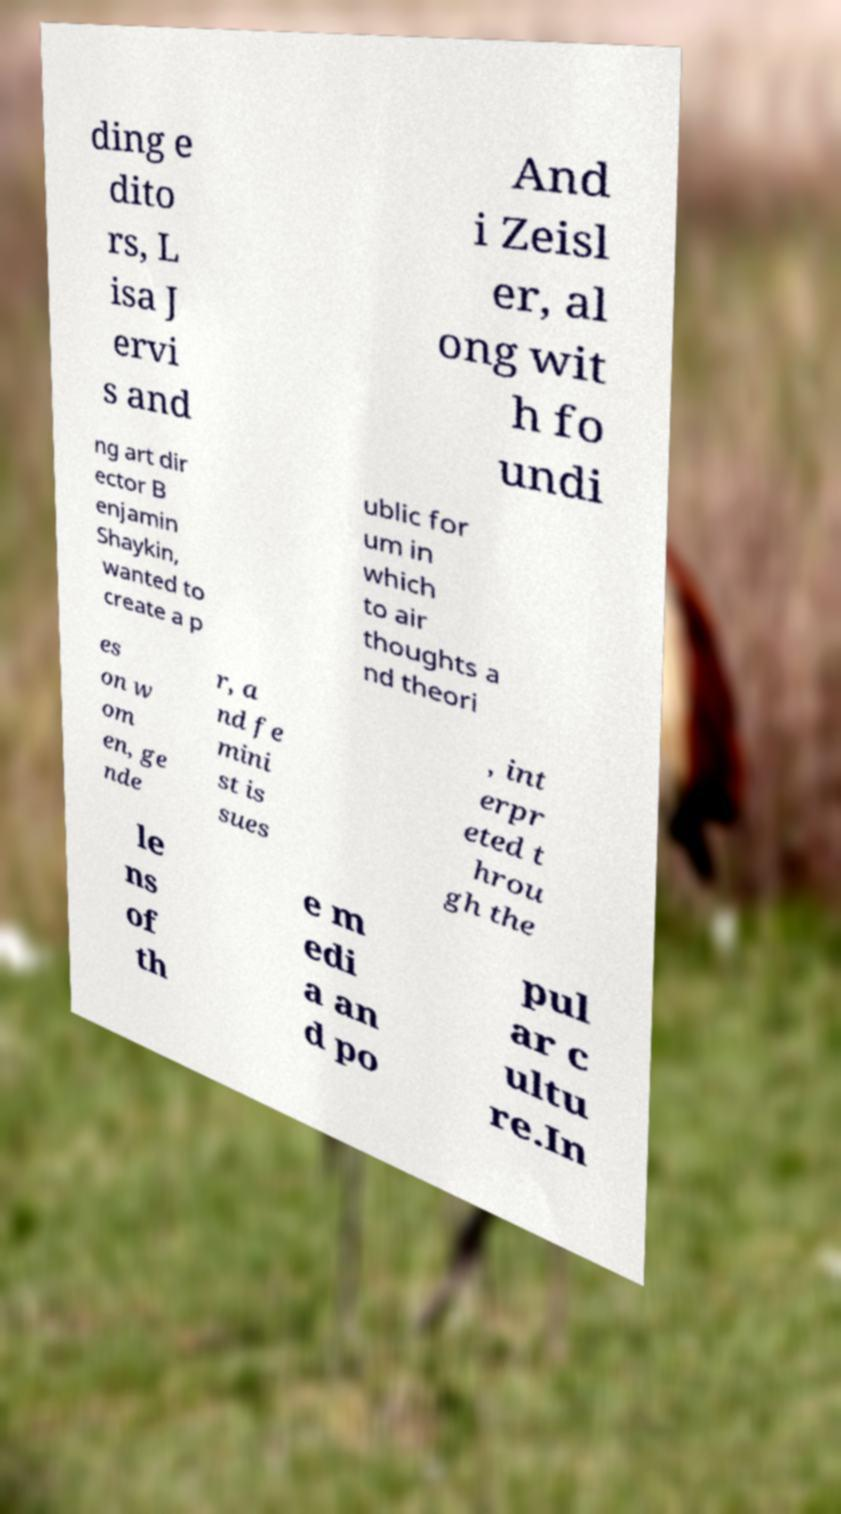What messages or text are displayed in this image? I need them in a readable, typed format. ding e dito rs, L isa J ervi s and And i Zeisl er, al ong wit h fo undi ng art dir ector B enjamin Shaykin, wanted to create a p ublic for um in which to air thoughts a nd theori es on w om en, ge nde r, a nd fe mini st is sues , int erpr eted t hrou gh the le ns of th e m edi a an d po pul ar c ultu re.In 